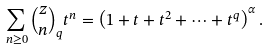Convert formula to latex. <formula><loc_0><loc_0><loc_500><loc_500>\sum _ { n \geq 0 } \binom { z } { n } _ { q } t ^ { n } = \left ( 1 + t + t ^ { 2 } + \cdots + t ^ { q } \right ) ^ { \alpha } .</formula> 